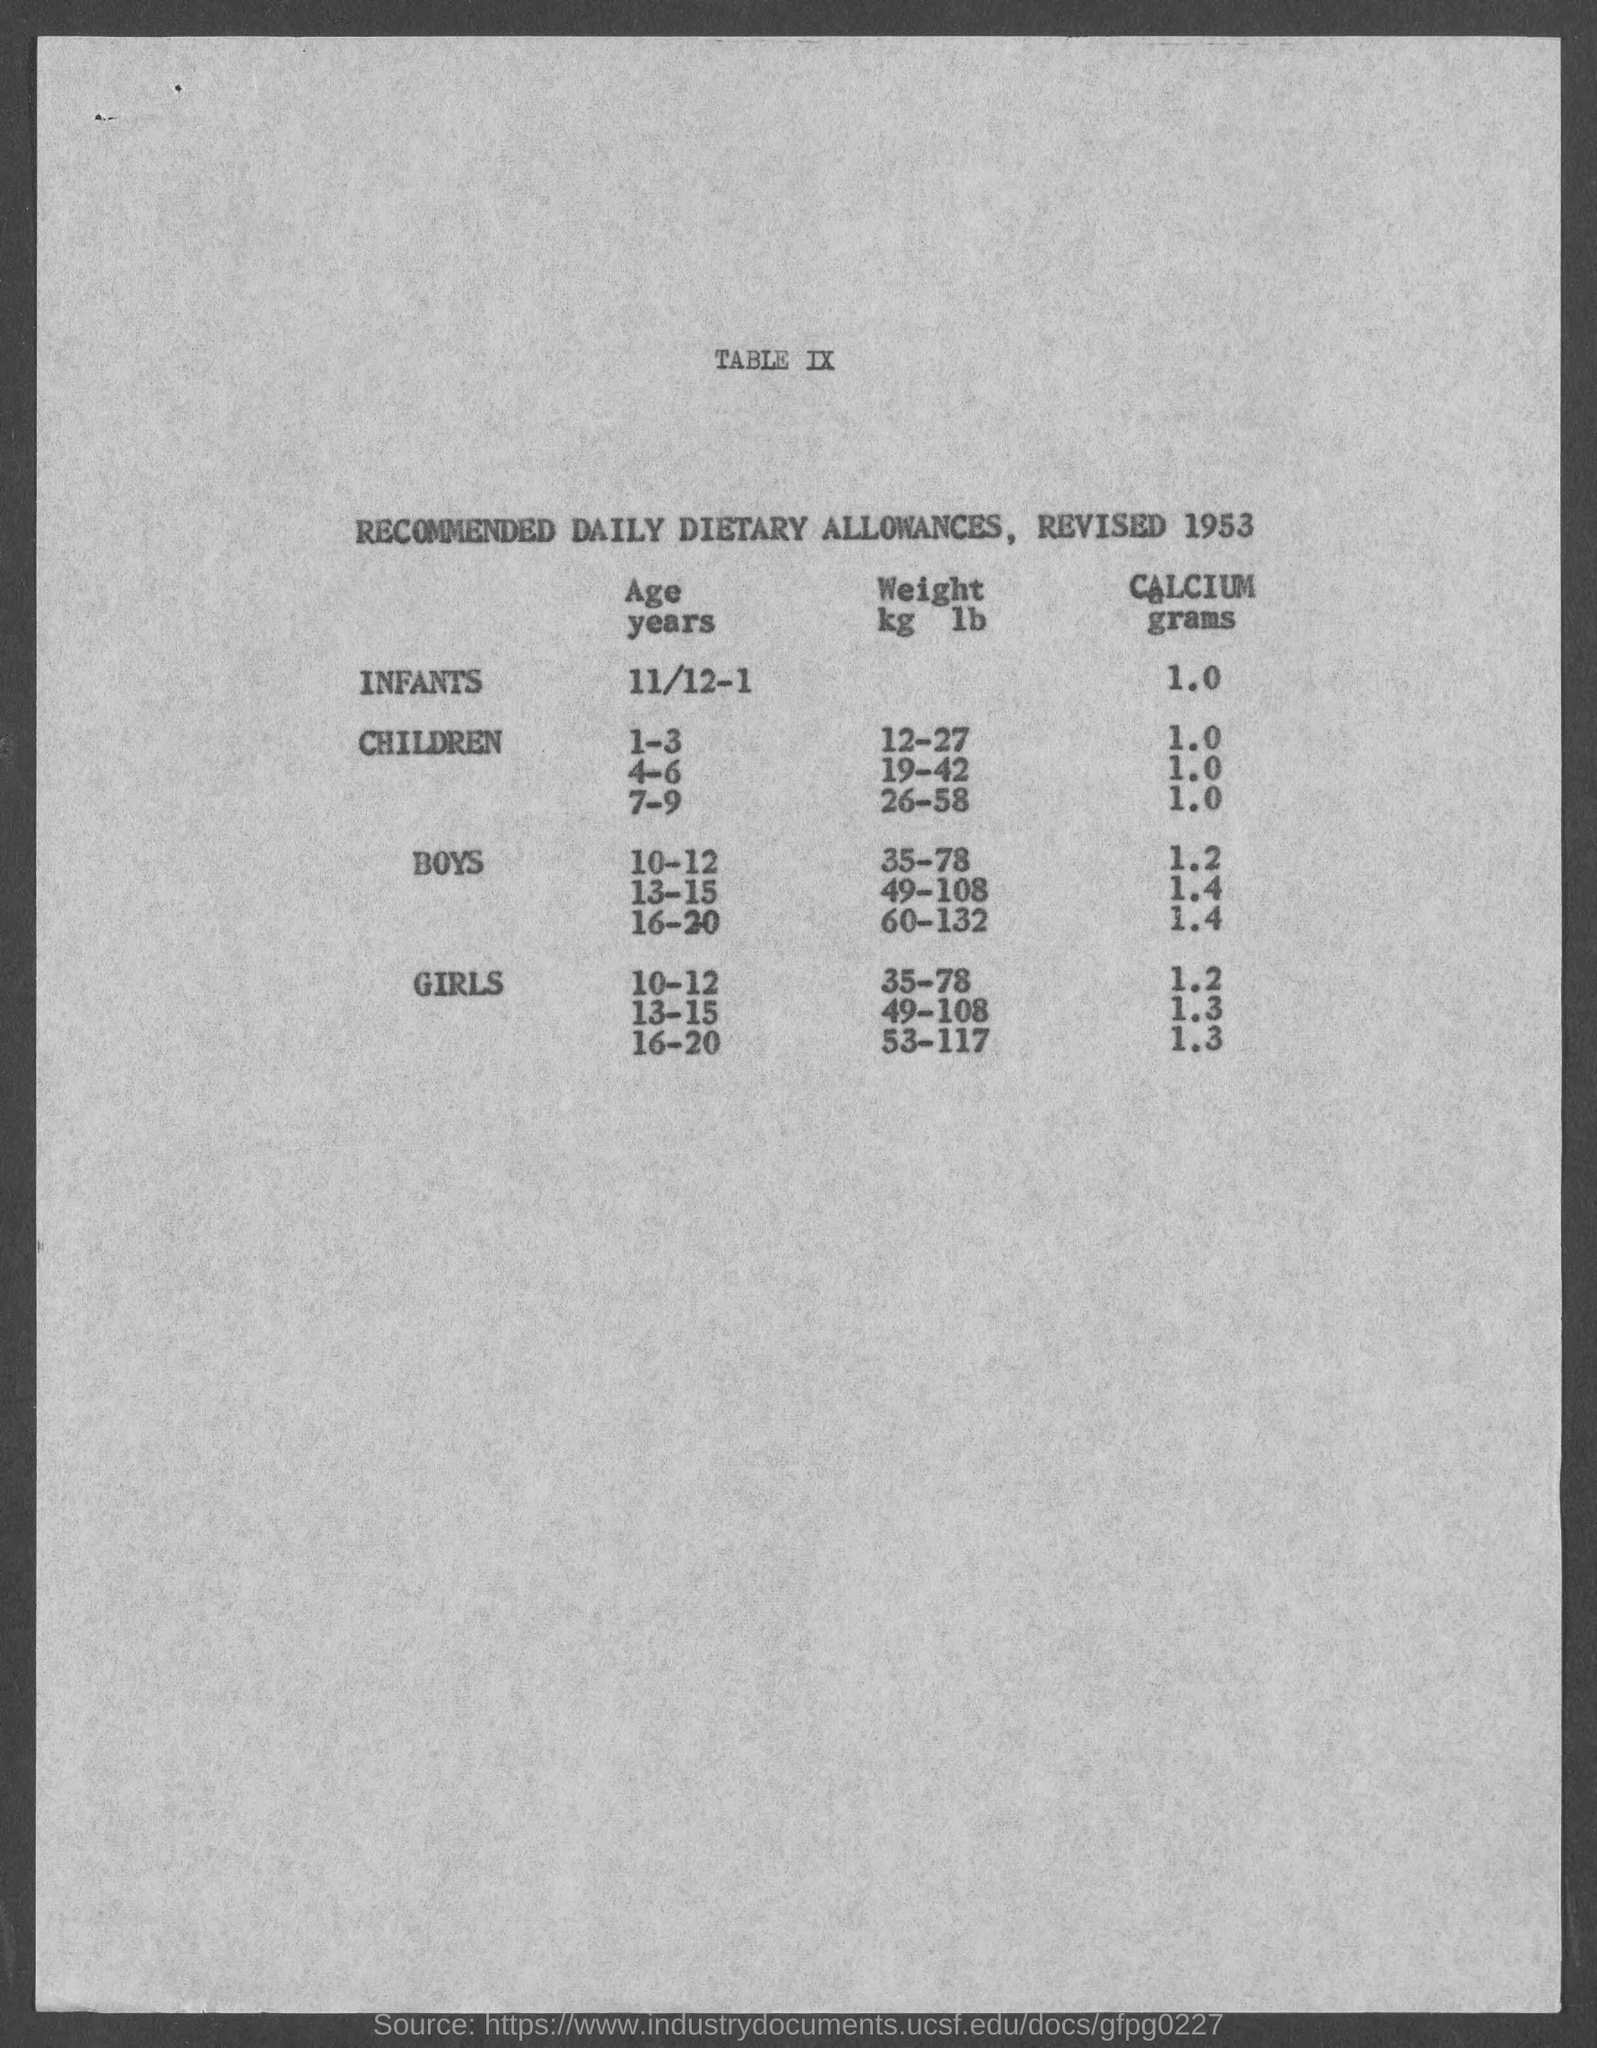Can you describe the source of this document? Certainly, the image shows a document titled 'TABLE IX', which outlines the 'RECOMMENDED DAILY DIETARY ALLOWANCES, REVISED 1953.' It provides guidelines for different age groups regarding weight and calcium intake. The source is listed at the bottom as an internet link to what appears to be a historical document repository from the University of California, San Francisco (UCSF). 